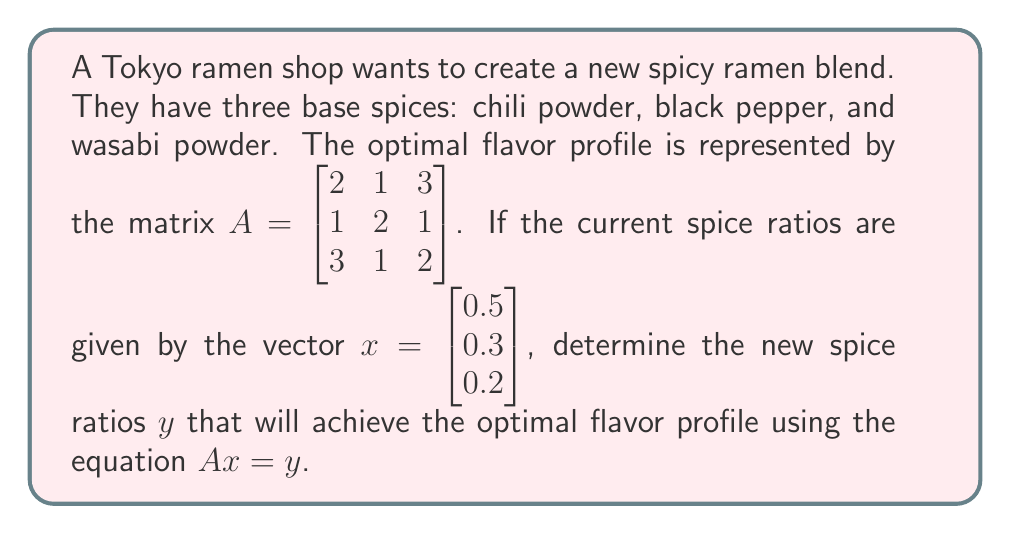Can you solve this math problem? To solve this problem, we need to perform matrix multiplication between $A$ and $x$ to find $y$. Let's break it down step-by-step:

1) We have $A = \begin{bmatrix} 2 & 1 & 3 \\ 1 & 2 & 1 \\ 3 & 1 & 2 \end{bmatrix}$ and $x = \begin{bmatrix} 0.5 \\ 0.3 \\ 0.2 \end{bmatrix}$

2) To multiply $A$ and $x$, we multiply each row of $A$ with $x$:

   $y_1 = (2 \times 0.5) + (1 \times 0.3) + (3 \times 0.2) = 1 + 0.3 + 0.6 = 1.9$
   
   $y_2 = (1 \times 0.5) + (2 \times 0.3) + (1 \times 0.2) = 0.5 + 0.6 + 0.2 = 1.3$
   
   $y_3 = (3 \times 0.5) + (1 \times 0.3) + (2 \times 0.2) = 1.5 + 0.3 + 0.4 = 2.2$

3) Therefore, $y = \begin{bmatrix} 1.9 \\ 1.3 \\ 2.2 \end{bmatrix}$

4) To interpret this result:
   - The first element (1.9) represents the new ratio for chili powder
   - The second element (1.3) represents the new ratio for black pepper
   - The third element (2.2) represents the new ratio for wasabi powder

These ratios are relative to each other and can be normalized if needed.
Answer: $y = \begin{bmatrix} 1.9 \\ 1.3 \\ 2.2 \end{bmatrix}$ 